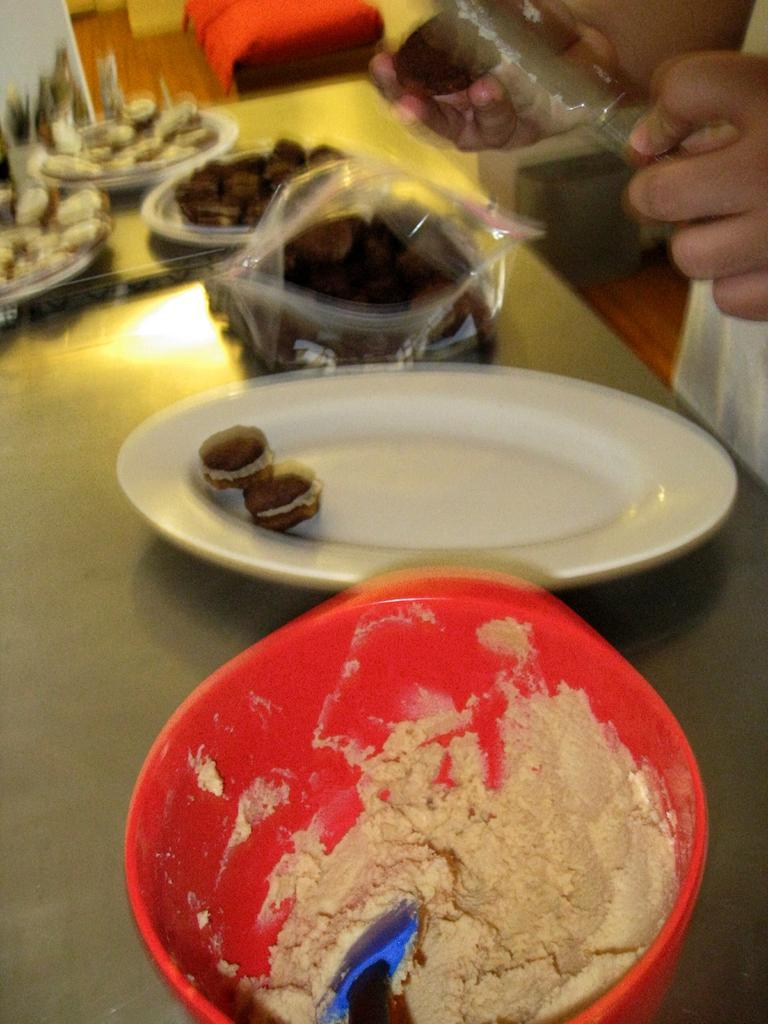In one or two sentences, can you explain what this image depicts? In this image we can see some kind of flour in the bowl, and at the back we can see a plate on the table. 